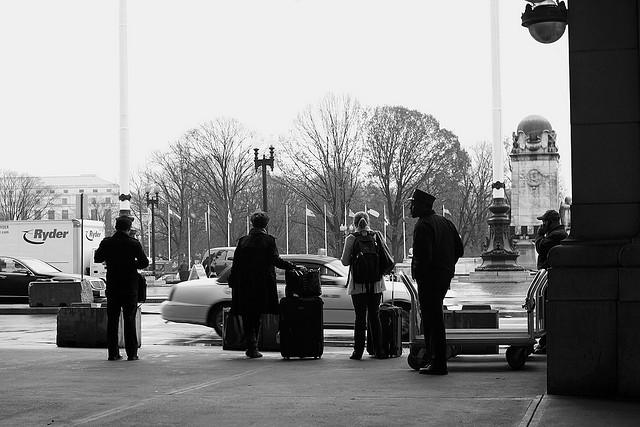What building did the people come from? Please explain your reasoning. airport. With the luggage, porter, and the area, it looks like they are at a hotel. 